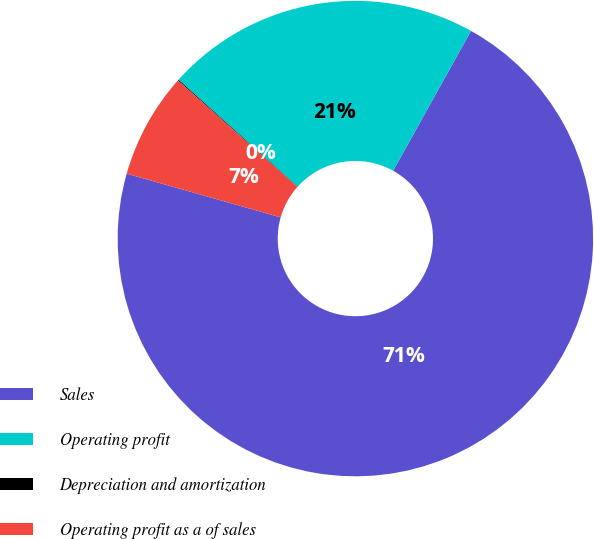<chart> <loc_0><loc_0><loc_500><loc_500><pie_chart><fcel>Sales<fcel>Operating profit<fcel>Depreciation and amortization<fcel>Operating profit as a of sales<nl><fcel>71.32%<fcel>21.44%<fcel>0.06%<fcel>7.18%<nl></chart> 